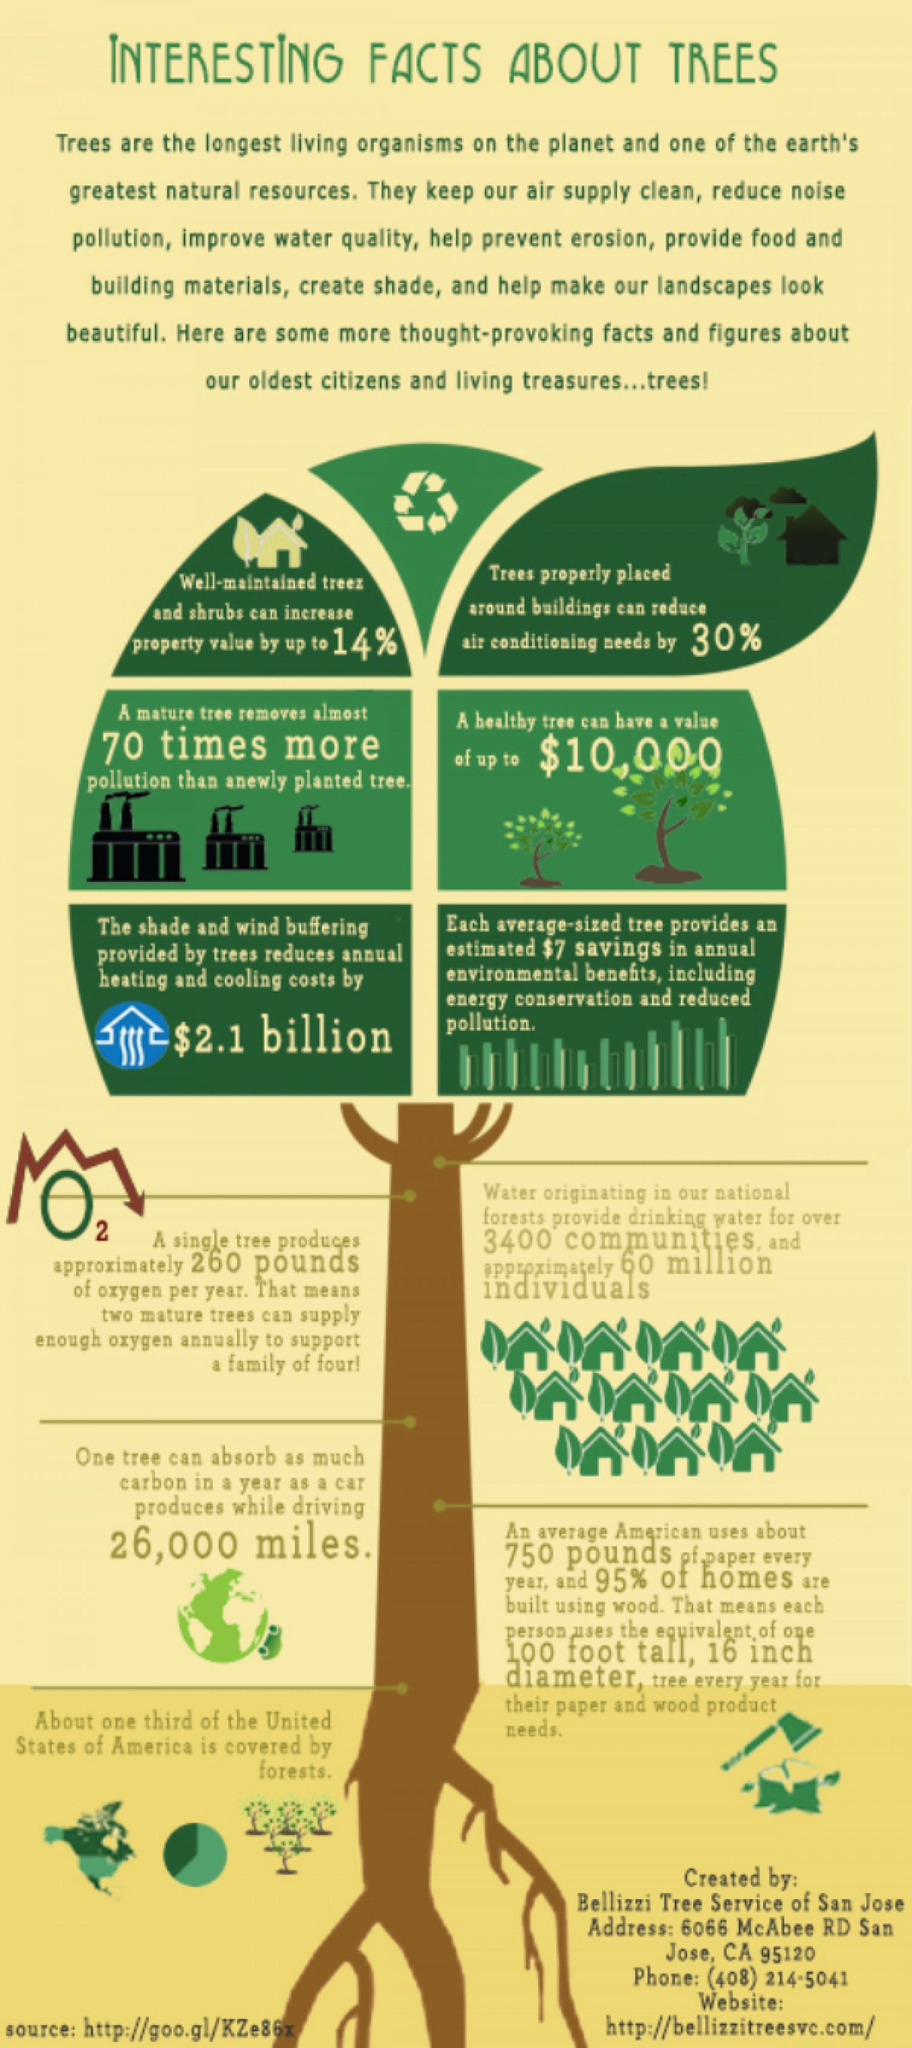Outline some significant characteristics in this image. The reduction in cooling appliances due to trees is 30%, which results in a decrease compared to the original state without trees. 